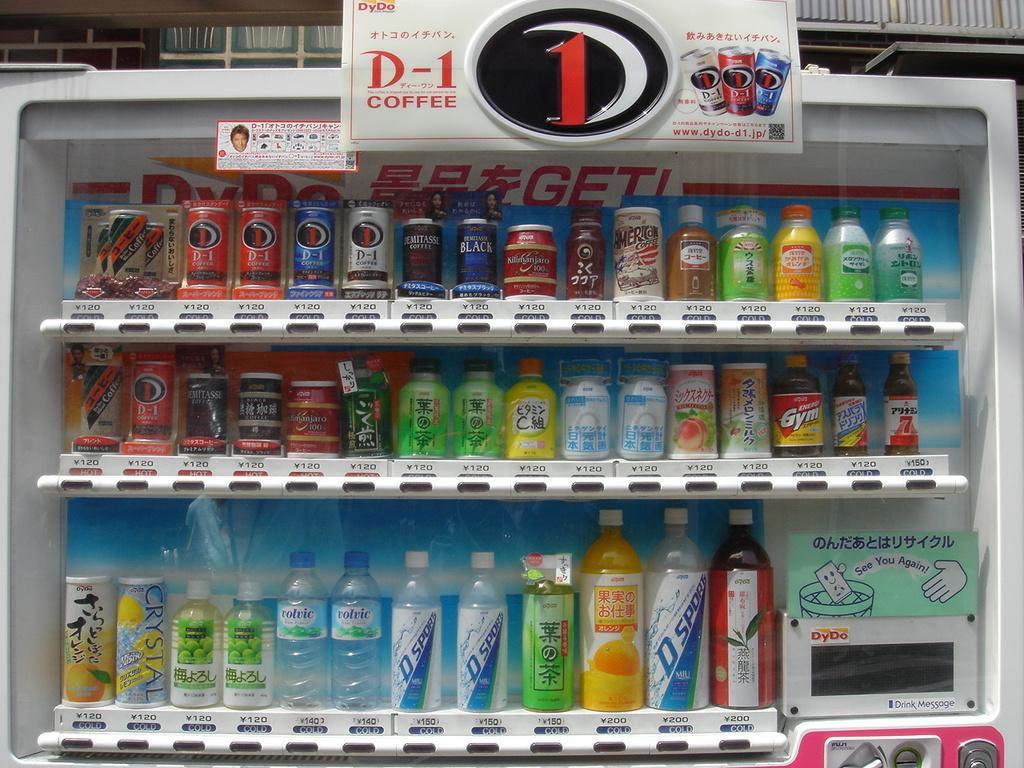<image>
Offer a succinct explanation of the picture presented. Vending machine with many drinks that say D-1 Coffee on the top. 